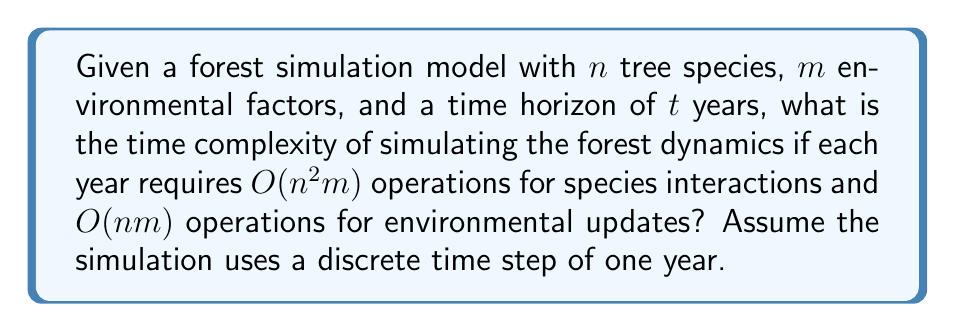Solve this math problem. To determine the computational feasibility of simulating long-term forest dynamics, we need to analyze the time complexity of the given simulation model. Let's break down the problem step by step:

1. For each year of the simulation:
   a. Species interactions: $O(n^2m)$ operations
   b. Environmental updates: $O(nm)$ operations

2. The total number of operations per year is the sum of these two components:
   $O(n^2m) + O(nm) = O(n^2m)$, as $n^2m$ dominates $nm$ for large $n$.

3. The simulation runs for $t$ years, so we multiply the yearly operations by $t$:
   $t \cdot O(n^2m) = O(tn^2m)$

Therefore, the overall time complexity of the forest dynamics simulation is $O(tn^2m)$.

To assess the computational feasibility:
- As the number of species $(n)$ increases, the complexity grows quadratically.
- The number of environmental factors $(m)$ contributes linearly to the complexity.
- The time horizon $(t)$ also contributes linearly to the complexity.

For practical considerations:
- If $n$, $m$, and $t$ are relatively small, the simulation may be feasible on standard computer hardware.
- For large old-growth forests with many species $(n)$, numerous environmental factors $(m)$, and long time horizons $(t)$, the simulation may become computationally intensive and require high-performance computing resources.
- Optimization techniques, such as parallel processing or approximation algorithms, might be necessary for simulating complex forest ecosystems over extended periods.
Answer: The time complexity of the forest dynamics simulation is $O(tn^2m)$, where $t$ is the number of years, $n$ is the number of tree species, and $m$ is the number of environmental factors. 